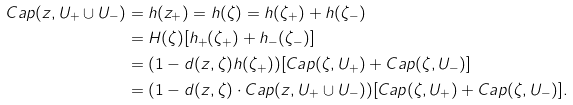Convert formula to latex. <formula><loc_0><loc_0><loc_500><loc_500>C a p ( z , U _ { + } \cup U _ { - } ) & = h ( z _ { + } ) = h ( \zeta ) = h ( \zeta _ { + } ) + h ( \zeta _ { - } ) \\ & = H ( \zeta ) [ h _ { + } ( \zeta _ { + } ) + h _ { - } ( \zeta _ { - } ) ] \\ & = ( 1 - d ( z , \zeta ) h ( \zeta _ { + } ) ) [ C a p ( \zeta , U _ { + } ) + C a p ( \zeta , U _ { - } ) ] \\ & = ( 1 - d ( z , \zeta ) \cdot C a p ( z , U _ { + } \cup U _ { - } ) ) [ C a p ( \zeta , U _ { + } ) + C a p ( \zeta , U _ { - } ) ] .</formula> 